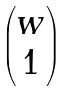<formula> <loc_0><loc_0><loc_500><loc_500>\begin{pmatrix} w \\ 1 \end{pmatrix}</formula> 